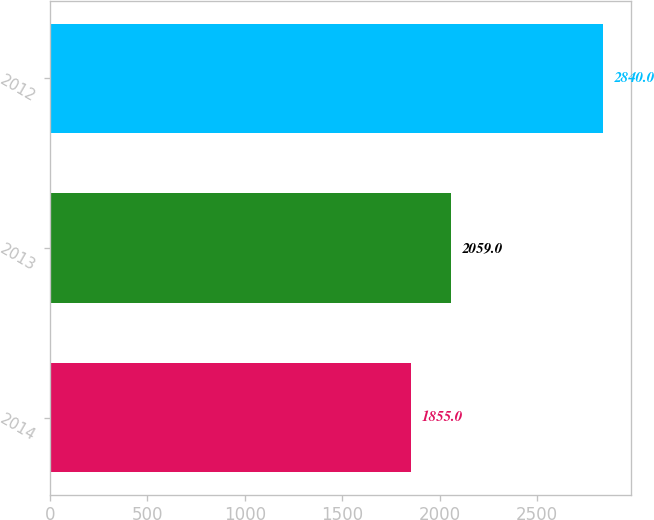Convert chart. <chart><loc_0><loc_0><loc_500><loc_500><bar_chart><fcel>2014<fcel>2013<fcel>2012<nl><fcel>1855<fcel>2059<fcel>2840<nl></chart> 